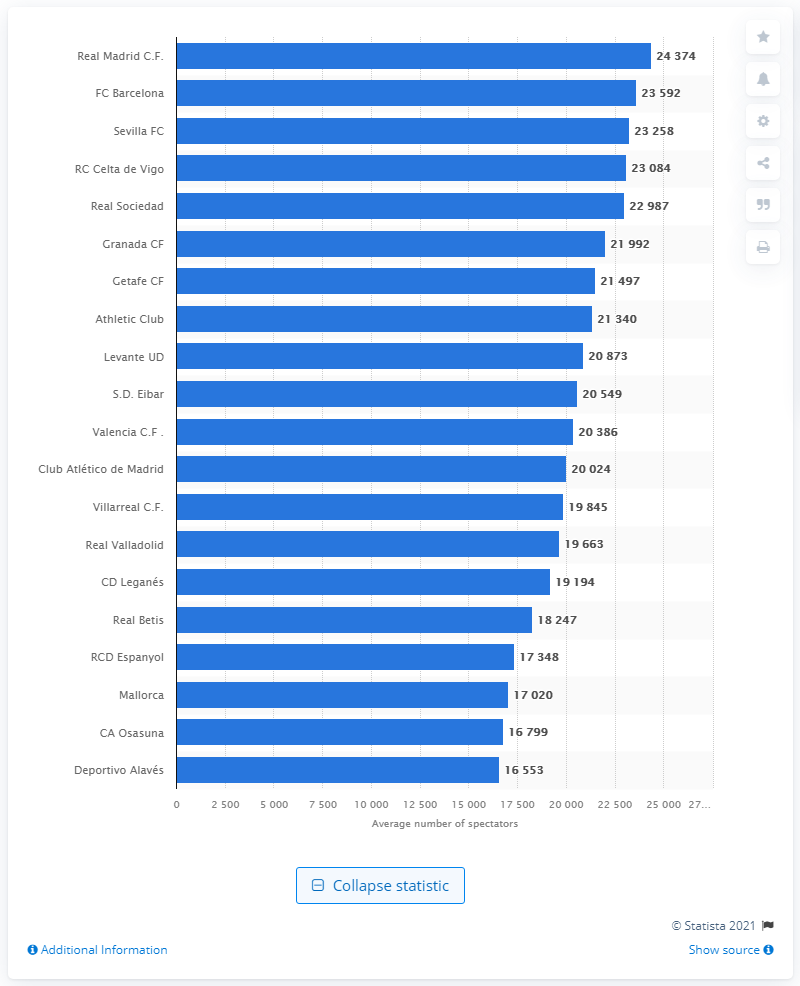List a handful of essential elements in this visual. In the 2019/2020 season, the average attendance at Real Madrid's away matches was 24,374 fans. During the 2019/2020 season, the average attendance at away matches for FC Barcelona and Club Atlético de Madrid was approximately 23,084 fans. 